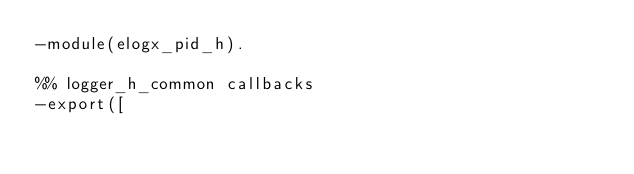Convert code to text. <code><loc_0><loc_0><loc_500><loc_500><_Erlang_>-module(elogx_pid_h).

%% logger_h_common callbacks
-export([</code> 